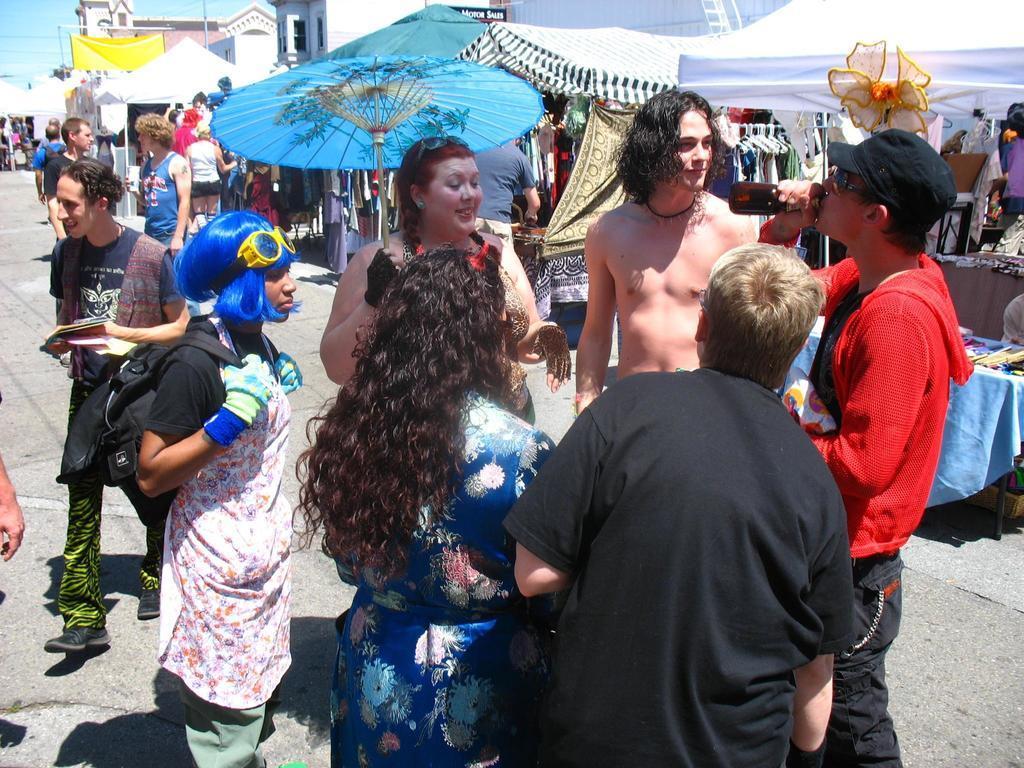Could you give a brief overview of what you see in this image? In this image we can see a group of people standing on the ground. In that a man is holding a bottle. On the backside we can see some objects on the table, an outdoor umbrella, some tents, some clothes to the hangers, a curtain, a banner, pole, a building, ladder and the sky which looks cloudy. 